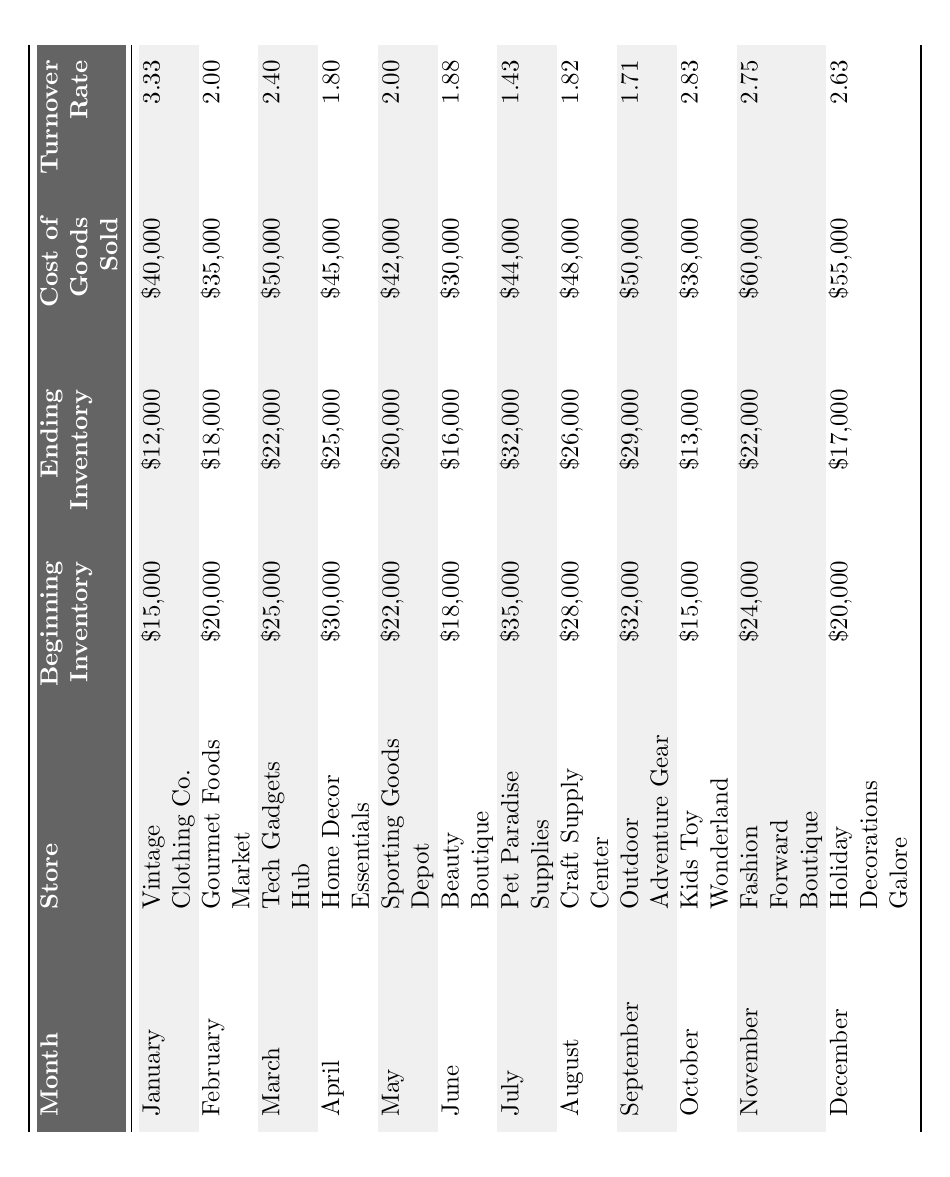What is the Inventory Turnover Rate for Home Decor Essentials in April? The table directly lists the Inventory Turnover Rate for Home Decor Essentials in April, which is 1.80.
Answer: 1.80 What was the Cost of Goods Sold for November? The table shows that the Cost of Goods Sold for November is $60,000.
Answer: $60,000 Which store had the highest Inventory Turnover Rate, and what was it? The table indicates that Vintage Clothing Co. had the highest Inventory Turnover Rate of 3.33 in January.
Answer: Vintage Clothing Co., 3.33 What is the difference in Cost of Goods Sold between March and June? The Cost of Goods Sold for March is $50,000, and for June it is $30,000. The difference is $50,000 - $30,000 = $20,000.
Answer: $20,000 What was the average Inventory Turnover Rate across all stores for the year? The turnover rates are 3.33, 2.00, 2.40, 1.80, 2.00, 1.88, 1.43, 1.82, 1.71, 2.83, 2.75, and 2.63. Summing these gives 23.71, and dividing by 12 gives an average of 1.976.
Answer: 1.98 Did any store have an Inventory Turnover Rate lower than 2.00 in June? The table lists the Inventory Turnover Rate for June as 1.88, which is below 2.00, indicating a yes answer.
Answer: Yes Which month had the lowest Inventory Turnover Rate, and what was the rate? The lowest rate is 1.43, found in July for Pet Paradise Supplies, according to the table.
Answer: July, 1.43 What is the total Beginning Inventory for all stores in October and December combined? October's Beginning Inventory is $15,000, and December's is $20,000. Adding these gives $15,000 + $20,000 = $35,000.
Answer: $35,000 Was the Ending Inventory for Gourmet Foods Market higher than that for Home Decor Essentials? The Ending Inventory for Gourmet Foods Market is $18,000, while for Home Decor Essentials it is $25,000. Since 18,000 is less than 25,000, the answer is no.
Answer: No If we compare the Cost of Goods Sold for Sporting Goods Depot and Outdoor Adventure Gear, which store had a higher amount? Sporting Goods Depot's Cost of Goods Sold is $42,000, while Outdoor Adventure Gear's is $50,000. Comparing these shows Outdoor Adventure Gear had a higher amount.
Answer: Outdoor Adventure Gear What is the percentage decrease in Beginning Inventory from May to June? May's Beginning Inventory is $22,000 and June's is $18,000. The decrease is $22,000 - $18,000 = $4,000. The percentage decrease is ($4,000 / $22,000) * 100 = 18.18%.
Answer: 18.18% 